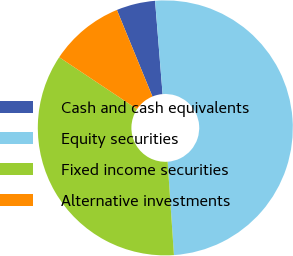Convert chart. <chart><loc_0><loc_0><loc_500><loc_500><pie_chart><fcel>Cash and cash equivalents<fcel>Equity securities<fcel>Fixed income securities<fcel>Alternative investments<nl><fcel>4.92%<fcel>50.2%<fcel>35.43%<fcel>9.45%<nl></chart> 